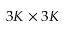Convert formula to latex. <formula><loc_0><loc_0><loc_500><loc_500>3 K \times 3 K</formula> 